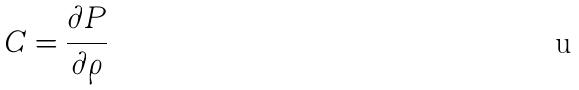Convert formula to latex. <formula><loc_0><loc_0><loc_500><loc_500>C = \frac { \partial P } { \partial \rho }</formula> 